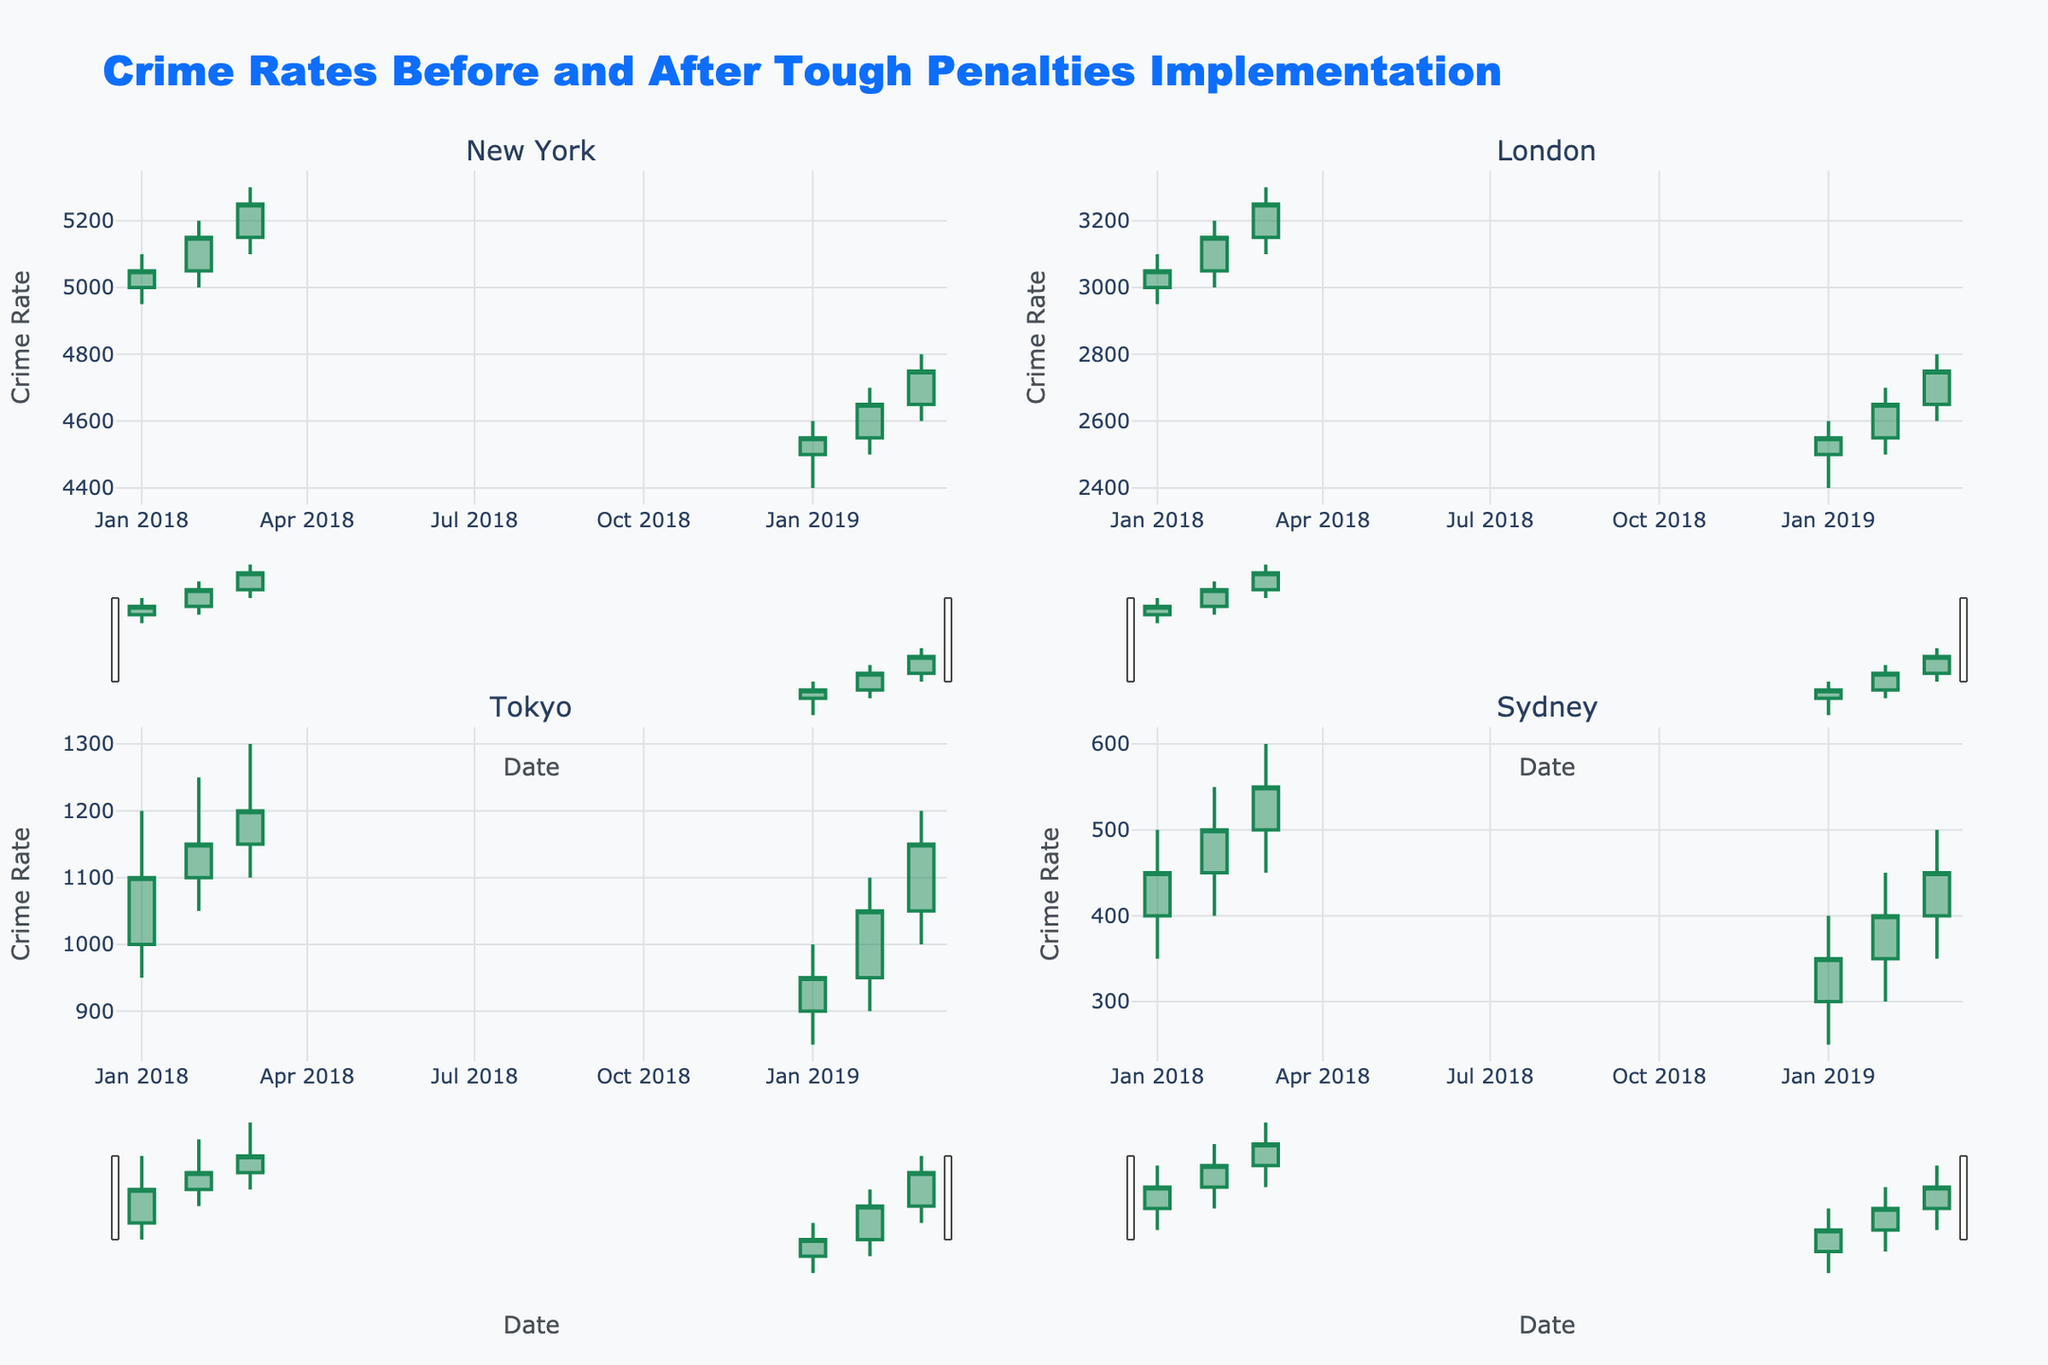What is the title of the plot? The title of the plot is located at the top center of the figure. It reads "Crime Rates Before and After Tough Penalties Implementation."
Answer: Crime Rates Before and After Tough Penalties Implementation Which region experienced the highest crime rate in March 2018? To answer this, look at the highest point of the candlestick for each region in March 2018. Compare these points to determine which region has the highest high.
Answer: New York What is the trend in crime rates for New York before and after the policy change? Observe the changes in the candlesticks for New York before and after the year 2019, when the policy change was implemented. Notice the drop in the highs and lows of the candlesticks.
Answer: Decreased Which region had the lowest closing crime rate in January 2019? Look at the lowest point of the candlestick's close in January 2019 for each region. Compare these values to find the lowest one.
Answer: Tokyo How many regions showed an increase in crime rates from February to March 2019? Compare the closing values of the candlesticks from February to March 2019 for each region. Count how many regions have a higher closing value in March than in February.
Answer: Three What is the difference in the high values between January 2018 and January 2019 in Sydney? Check the highest points of the candlesticks for Sydney in January 2018 and January 2019 and calculate the difference between these values.
Answer: 100 Which region's crime rate decreased the most from March 2018 to January 2019? Compare the high values of each region in March 2018 and January 2019. Subtract these values for each region to determine the region with the largest decrease.
Answer: Sydney What pattern do you observe in the candlestick colors for increasing versus decreasing crime rates? The colors of the candlesticks indicate the trend in crime rates. Green candlesticks represent an increase, while red candlesticks represent a decrease.
Answer: Green for increase, Red for decrease How much did the closing crime rate change for Tokyo from January 2018 to January 2019? Calculate the difference between the closing values of the candlestick for Tokyo in January 2018 and January 2019.
Answer: -150 